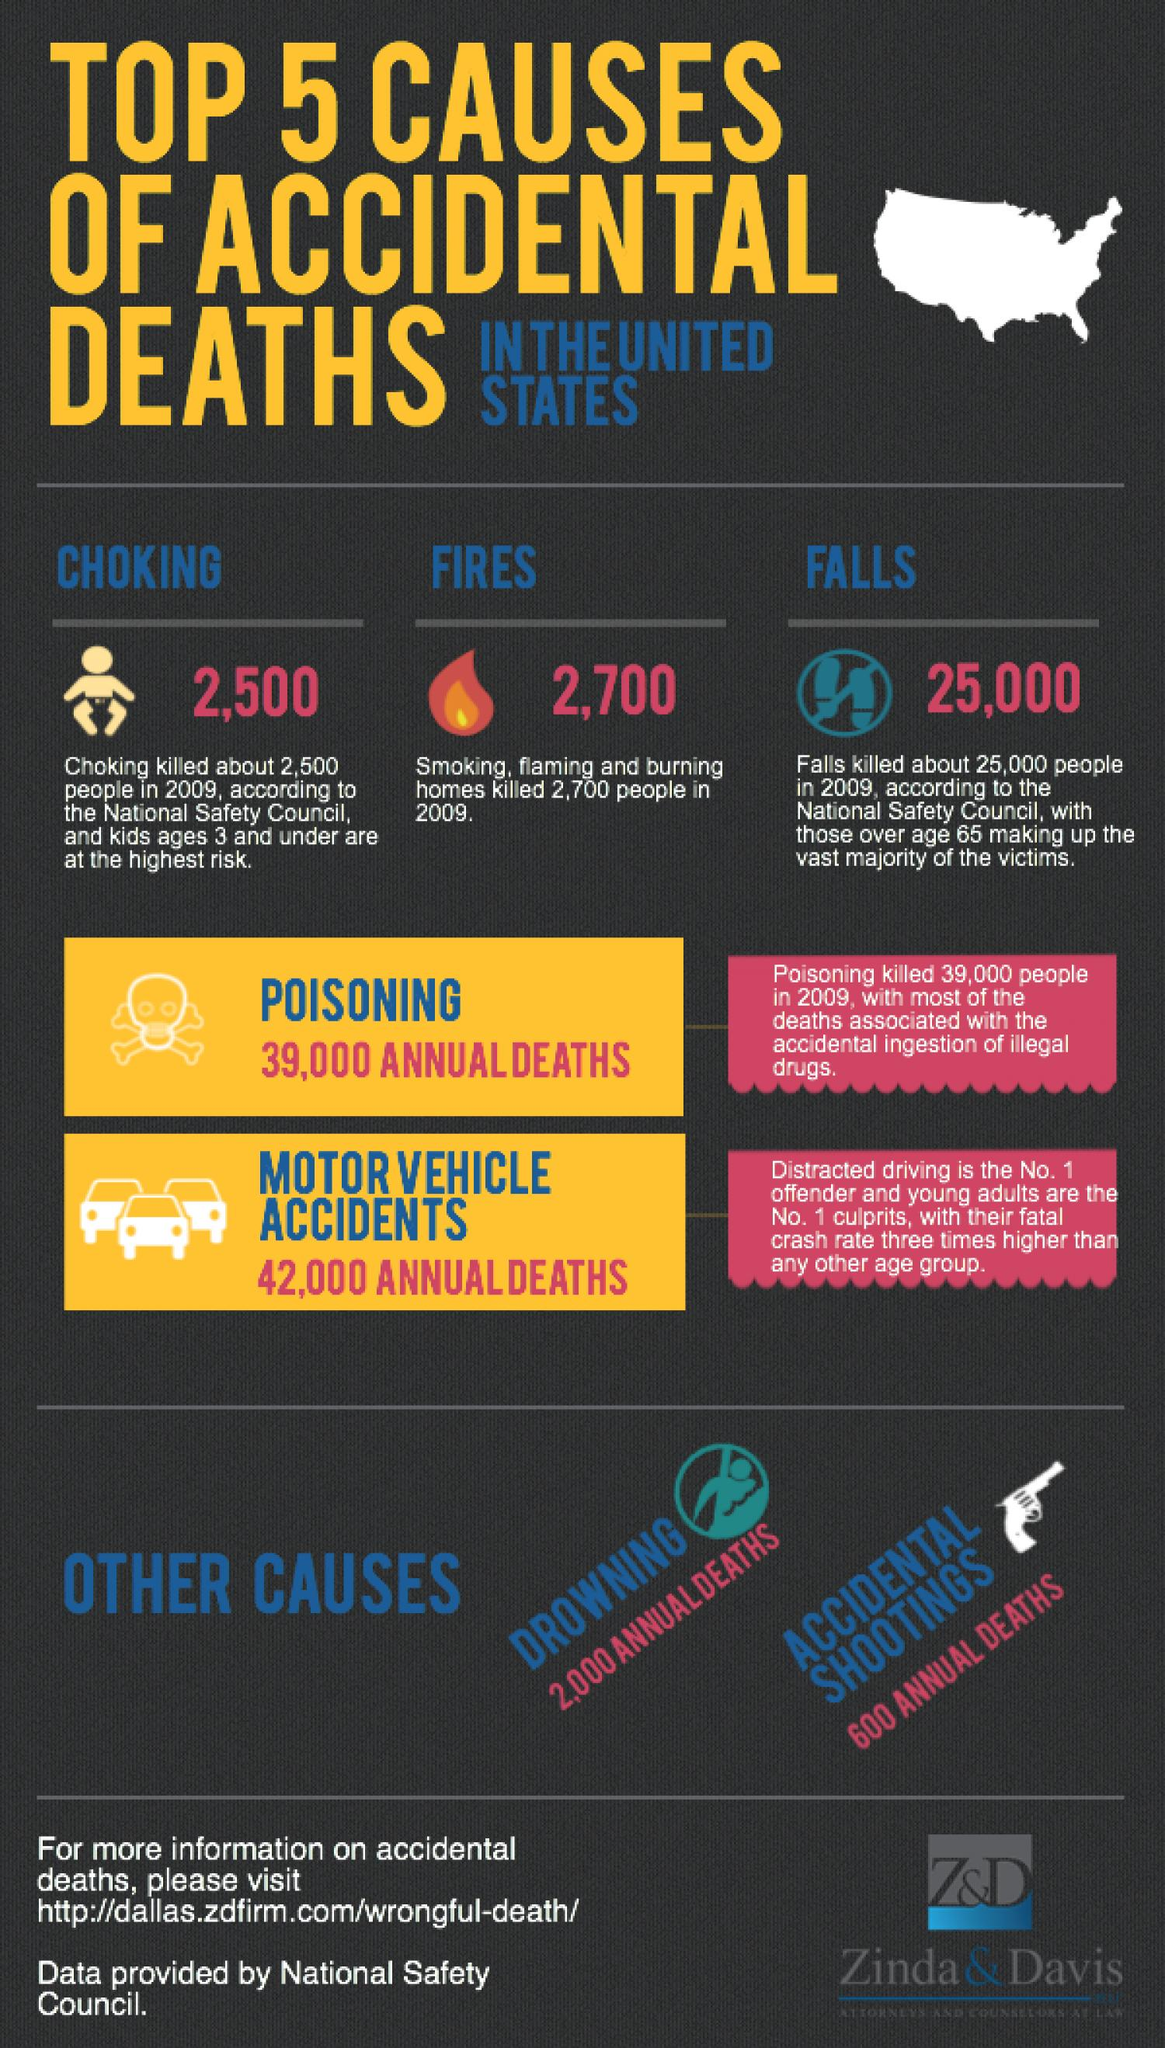Specify some key components in this picture. Poisoning is the second leading cause of accidental deaths. In 2009, in the United States, more people died as a result of drowning, falls, and accidental shootings than any other cause. Among the five reasons listed, motor vehicle accidents are the most significant cause of accidental deaths. The average number of annual deaths from drowning is approximately 2,000. 